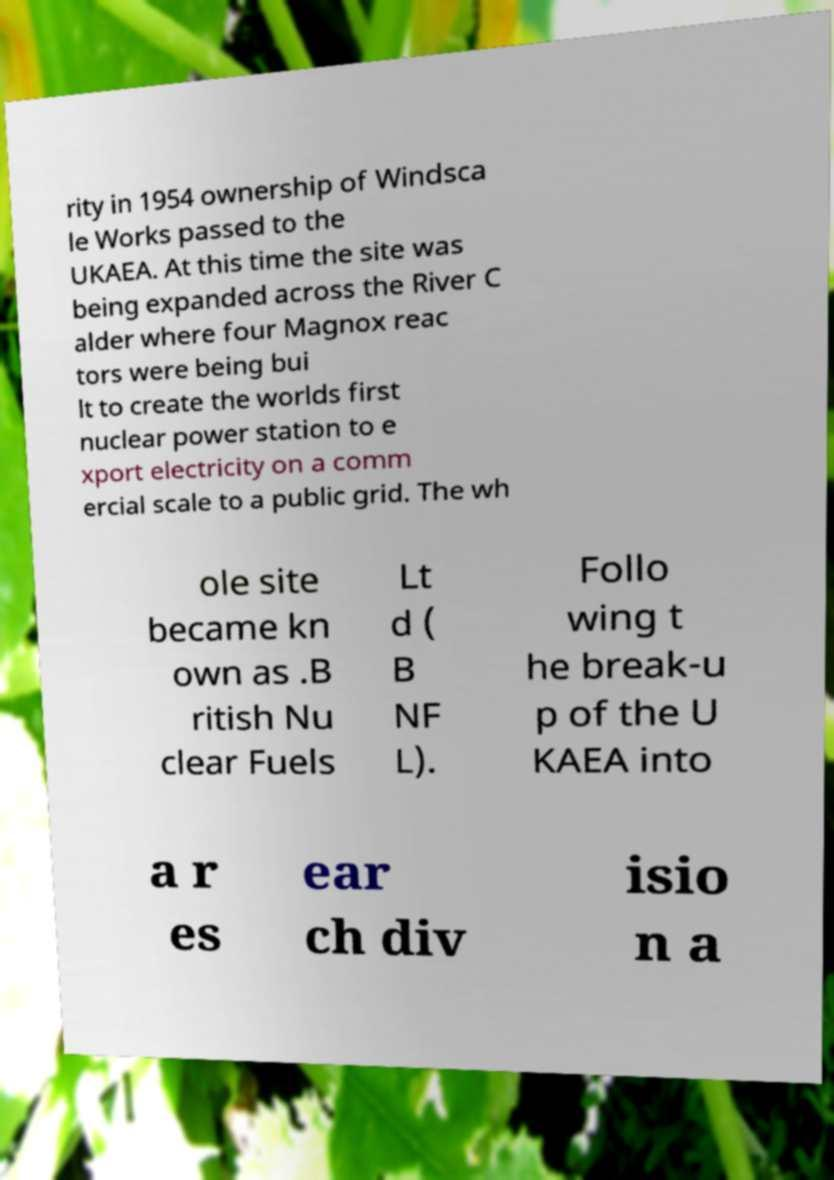Can you read and provide the text displayed in the image?This photo seems to have some interesting text. Can you extract and type it out for me? rity in 1954 ownership of Windsca le Works passed to the UKAEA. At this time the site was being expanded across the River C alder where four Magnox reac tors were being bui lt to create the worlds first nuclear power station to e xport electricity on a comm ercial scale to a public grid. The wh ole site became kn own as .B ritish Nu clear Fuels Lt d ( B NF L). Follo wing t he break-u p of the U KAEA into a r es ear ch div isio n a 